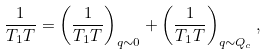Convert formula to latex. <formula><loc_0><loc_0><loc_500><loc_500>\frac { 1 } { T _ { 1 } T } = \left ( \frac { 1 } { T _ { 1 } T } \right ) _ { q \sim 0 } + \left ( \frac { 1 } { T _ { 1 } T } \right ) _ { q \sim Q _ { c } } ,</formula> 